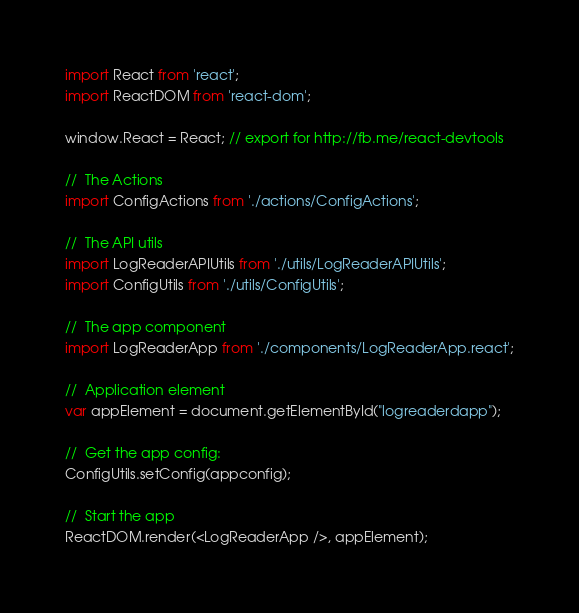<code> <loc_0><loc_0><loc_500><loc_500><_JavaScript_>import React from 'react';
import ReactDOM from 'react-dom';

window.React = React; // export for http://fb.me/react-devtools

//  The Actions
import ConfigActions from './actions/ConfigActions';

//	The API utils
import LogReaderAPIUtils from './utils/LogReaderAPIUtils';
import ConfigUtils from './utils/ConfigUtils';

//	The app component
import LogReaderApp from './components/LogReaderApp.react';

//  Application element
var appElement = document.getElementById("logreaderdapp");

//	Get the app config:
ConfigUtils.setConfig(appconfig);

//	Start the app
ReactDOM.render(<LogReaderApp />, appElement);	
</code> 